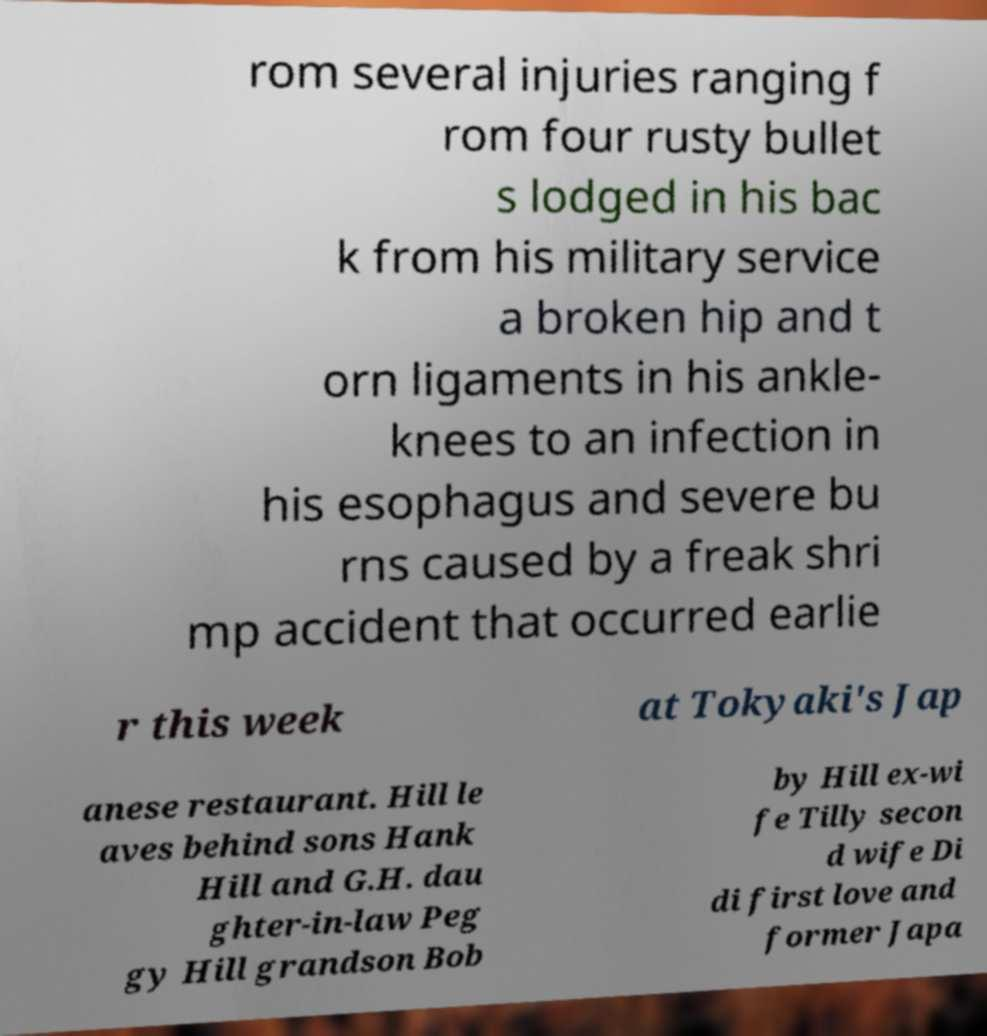Could you extract and type out the text from this image? rom several injuries ranging f rom four rusty bullet s lodged in his bac k from his military service a broken hip and t orn ligaments in his ankle- knees to an infection in his esophagus and severe bu rns caused by a freak shri mp accident that occurred earlie r this week at Tokyaki's Jap anese restaurant. Hill le aves behind sons Hank Hill and G.H. dau ghter-in-law Peg gy Hill grandson Bob by Hill ex-wi fe Tilly secon d wife Di di first love and former Japa 